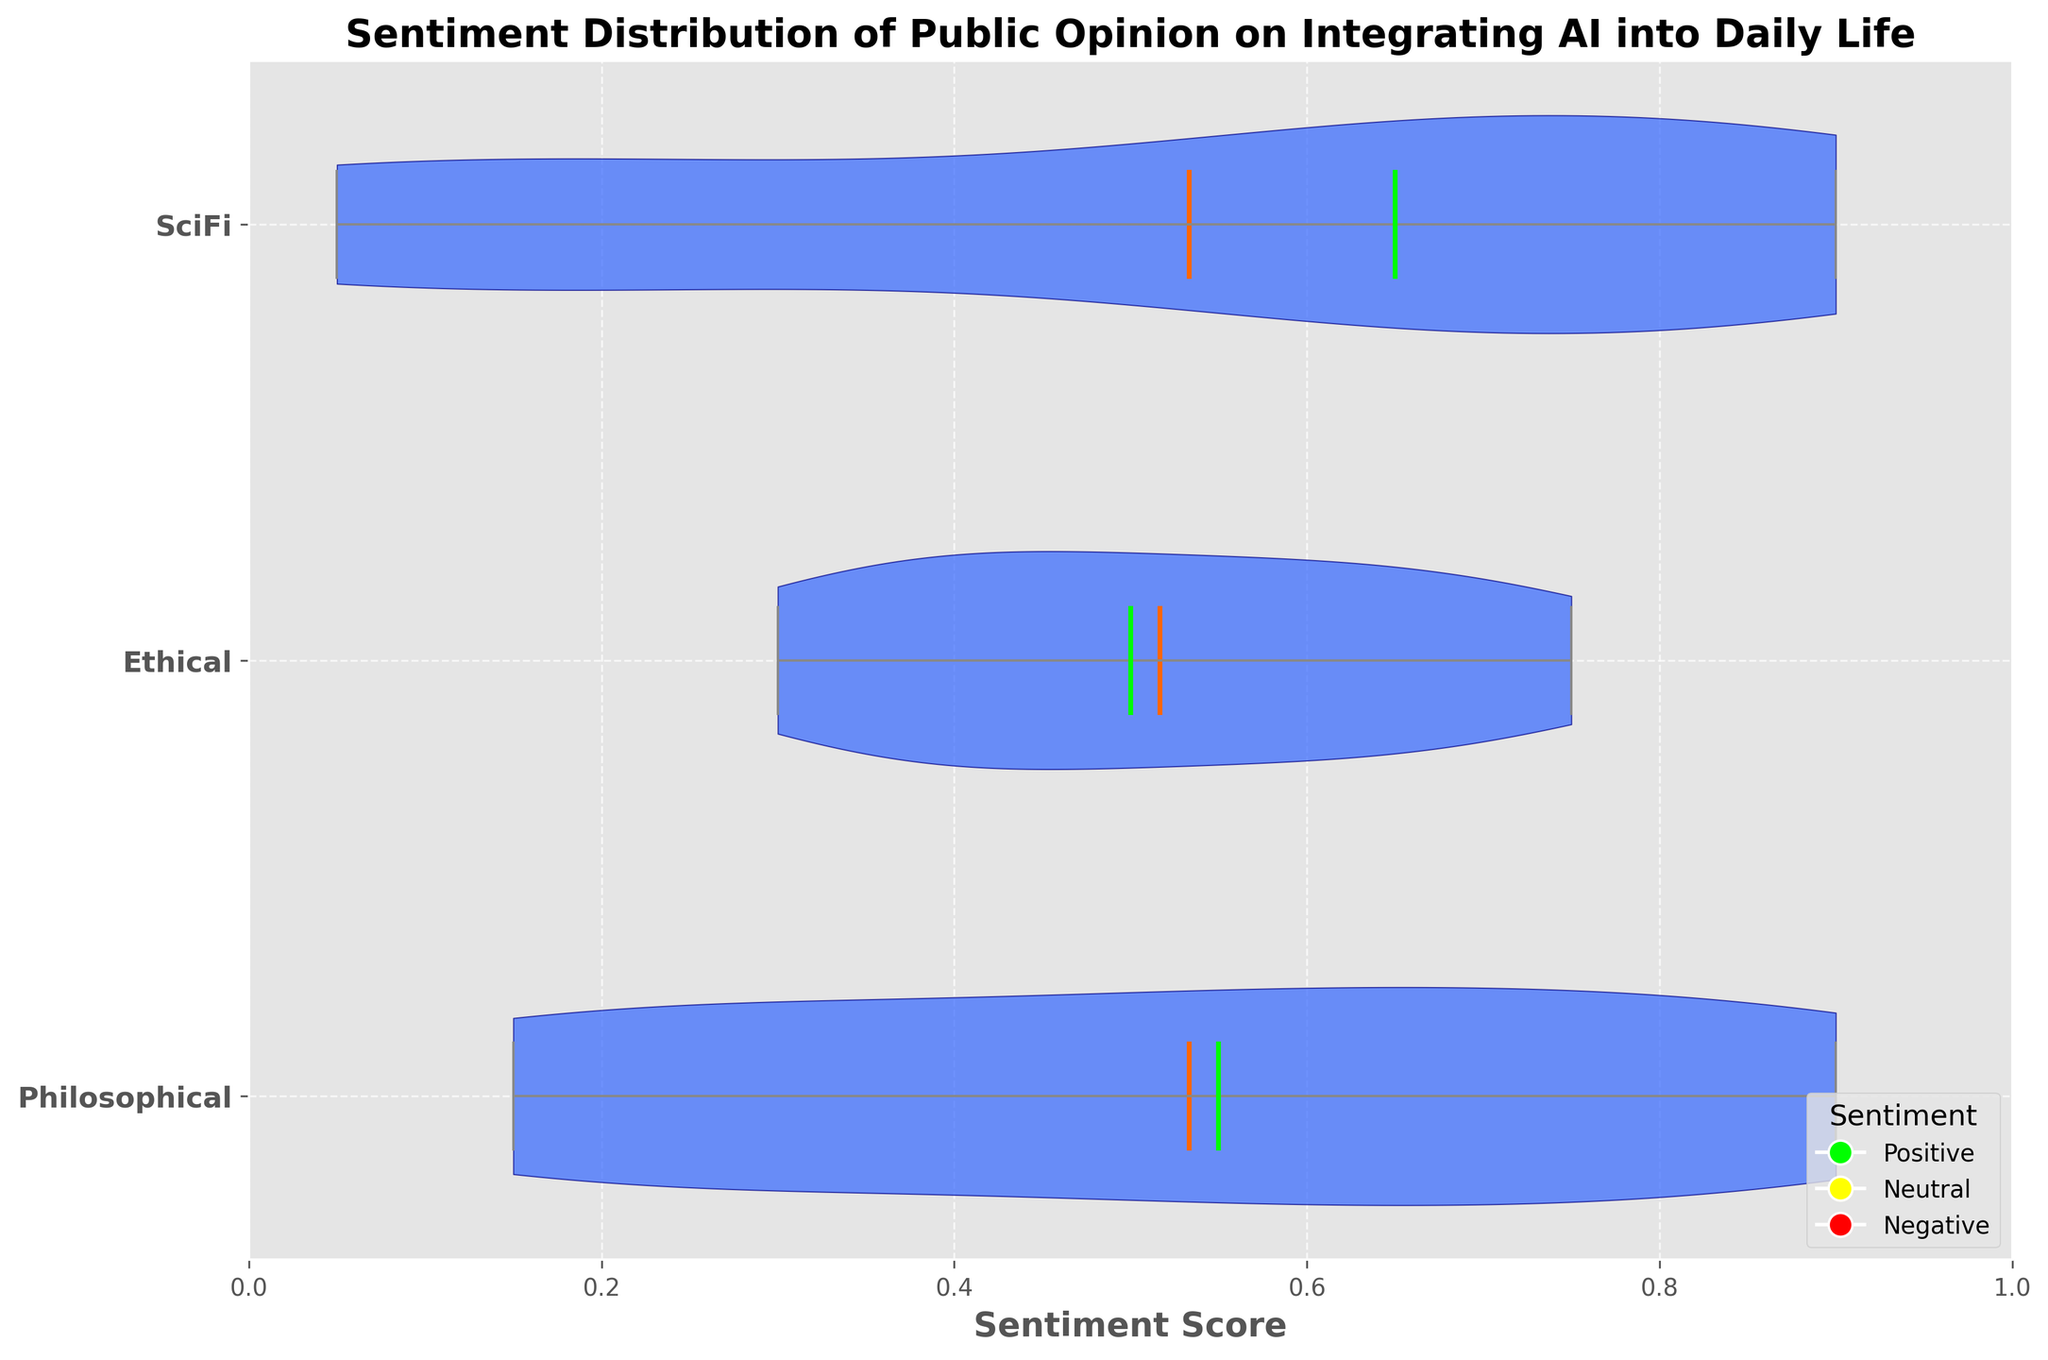What is the title of the chart? The title is located at the top of the chart and reads "Sentiment Distribution of Public Opinion on Integrating AI into Daily Life".
Answer: Sentiment Distribution of Public Opinion on Integrating AI into Daily Life What color represents the sentiment means in the chart? The sentiment means are represented by the color of the horizontal line that appears in the middle of the violin shapes. This color is orange.
Answer: Orange What is the median sentiment score for the 'Ethical' category? To find the median sentiment score for the 'Ethical' category, locate the position of the horizontal green line within the 'Ethical' section of the violin plot. This line represents the median value.
Answer: Approximately 0.5 Which category demonstrates the highest mean sentiment score? The mean sentiment scores are represented by orange lines within each category on the plot. By comparing the positions of these lines, it is evident which one is highest.
Answer: Philosophical Does the 'SciFi' sentiment category have a lower median value than the 'Philosophical' category? Compare the green median lines on the 'SciFi' and 'Philosophical' sections.
Answer: Yes What is the range of sentiment scores for the 'Philosophical' category? The range is determined by noting the minimum and maximum points of the violin plot for the 'Philosophical' category. These are shown by vertical areas occupied by the violin shape.
Answer: 0.15 to 0.9 How do the distributions of the sentiment scores compare across the three categories? The overall shapes of the violins indicate the distribution of sentiment scores. Comparing these shapes can reveal differences in spread and density.
Answer: The 'Philosophical' category shows a wider distribution with data points clustered primarily at higher values, the 'Ethical' category has a more central distribution, and the 'SciFi' category has a moderate spread with data points slightly skewed towards higher values What sentiment is shown to have the lowest sentiment score in the 'SciFi' category? Find the lowest point within the 'SciFi' violin plot which indicates the minimum sentiment score observed in this category.
Answer: 0.05 